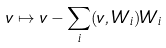Convert formula to latex. <formula><loc_0><loc_0><loc_500><loc_500>v \mapsto v - \sum _ { i } ( v , W _ { i } ) W _ { i }</formula> 